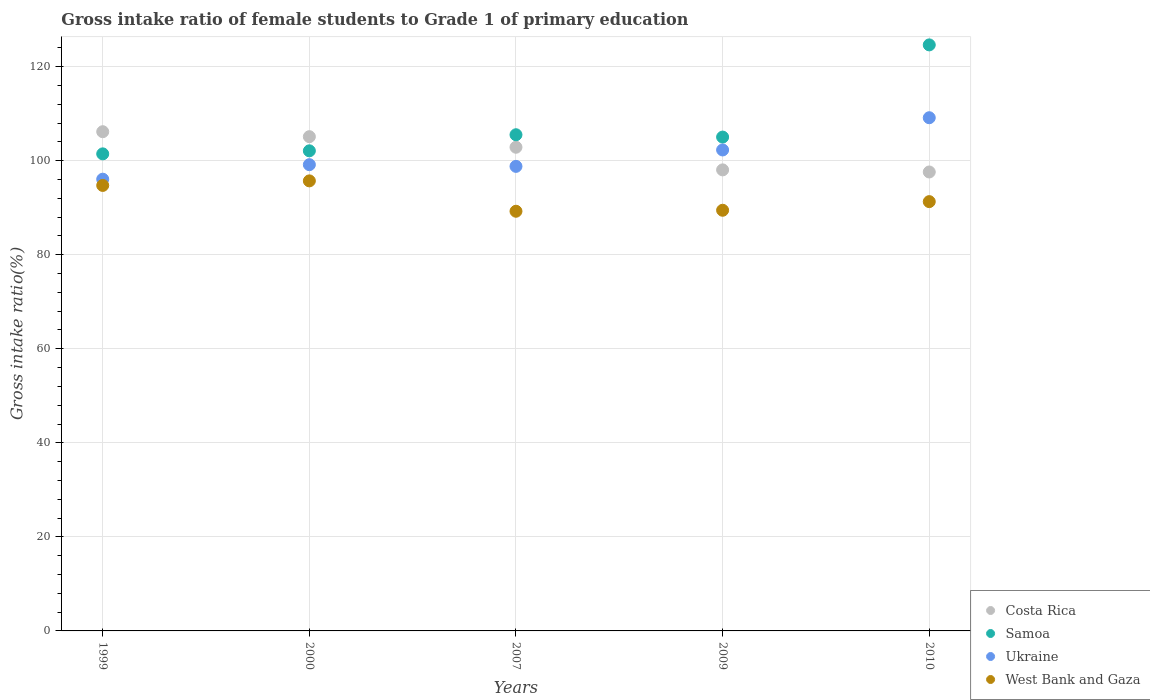Is the number of dotlines equal to the number of legend labels?
Make the answer very short. Yes. What is the gross intake ratio in Ukraine in 2010?
Provide a short and direct response. 109.14. Across all years, what is the maximum gross intake ratio in Costa Rica?
Keep it short and to the point. 106.16. Across all years, what is the minimum gross intake ratio in Samoa?
Provide a succinct answer. 101.45. In which year was the gross intake ratio in Costa Rica maximum?
Give a very brief answer. 1999. What is the total gross intake ratio in West Bank and Gaza in the graph?
Give a very brief answer. 460.45. What is the difference between the gross intake ratio in West Bank and Gaza in 2007 and that in 2009?
Keep it short and to the point. -0.21. What is the difference between the gross intake ratio in Ukraine in 2000 and the gross intake ratio in West Bank and Gaza in 2009?
Ensure brevity in your answer.  9.69. What is the average gross intake ratio in West Bank and Gaza per year?
Offer a very short reply. 92.09. In the year 2007, what is the difference between the gross intake ratio in Costa Rica and gross intake ratio in Samoa?
Give a very brief answer. -2.66. In how many years, is the gross intake ratio in West Bank and Gaza greater than 108 %?
Offer a terse response. 0. What is the ratio of the gross intake ratio in West Bank and Gaza in 2007 to that in 2010?
Keep it short and to the point. 0.98. What is the difference between the highest and the second highest gross intake ratio in Samoa?
Keep it short and to the point. 19.11. What is the difference between the highest and the lowest gross intake ratio in Costa Rica?
Make the answer very short. 8.56. In how many years, is the gross intake ratio in Samoa greater than the average gross intake ratio in Samoa taken over all years?
Your response must be concise. 1. Is the sum of the gross intake ratio in West Bank and Gaza in 2007 and 2010 greater than the maximum gross intake ratio in Samoa across all years?
Provide a short and direct response. Yes. Is it the case that in every year, the sum of the gross intake ratio in Ukraine and gross intake ratio in Costa Rica  is greater than the sum of gross intake ratio in Samoa and gross intake ratio in West Bank and Gaza?
Your answer should be compact. No. Is it the case that in every year, the sum of the gross intake ratio in West Bank and Gaza and gross intake ratio in Ukraine  is greater than the gross intake ratio in Costa Rica?
Provide a succinct answer. Yes. Is the gross intake ratio in Ukraine strictly greater than the gross intake ratio in Samoa over the years?
Give a very brief answer. No. Is the gross intake ratio in Ukraine strictly less than the gross intake ratio in Samoa over the years?
Keep it short and to the point. Yes. How many dotlines are there?
Provide a short and direct response. 4. How many years are there in the graph?
Offer a very short reply. 5. Where does the legend appear in the graph?
Your response must be concise. Bottom right. How are the legend labels stacked?
Provide a succinct answer. Vertical. What is the title of the graph?
Offer a very short reply. Gross intake ratio of female students to Grade 1 of primary education. What is the label or title of the X-axis?
Give a very brief answer. Years. What is the label or title of the Y-axis?
Your response must be concise. Gross intake ratio(%). What is the Gross intake ratio(%) in Costa Rica in 1999?
Your response must be concise. 106.16. What is the Gross intake ratio(%) of Samoa in 1999?
Make the answer very short. 101.45. What is the Gross intake ratio(%) of Ukraine in 1999?
Your answer should be compact. 96.07. What is the Gross intake ratio(%) of West Bank and Gaza in 1999?
Give a very brief answer. 94.74. What is the Gross intake ratio(%) in Costa Rica in 2000?
Offer a terse response. 105.11. What is the Gross intake ratio(%) of Samoa in 2000?
Provide a succinct answer. 102.1. What is the Gross intake ratio(%) in Ukraine in 2000?
Your answer should be very brief. 99.15. What is the Gross intake ratio(%) of West Bank and Gaza in 2000?
Your answer should be compact. 95.71. What is the Gross intake ratio(%) in Costa Rica in 2007?
Make the answer very short. 102.86. What is the Gross intake ratio(%) in Samoa in 2007?
Ensure brevity in your answer.  105.52. What is the Gross intake ratio(%) in Ukraine in 2007?
Offer a very short reply. 98.79. What is the Gross intake ratio(%) of West Bank and Gaza in 2007?
Provide a succinct answer. 89.25. What is the Gross intake ratio(%) of Costa Rica in 2009?
Offer a terse response. 98.05. What is the Gross intake ratio(%) in Samoa in 2009?
Your response must be concise. 105.02. What is the Gross intake ratio(%) of Ukraine in 2009?
Provide a short and direct response. 102.28. What is the Gross intake ratio(%) in West Bank and Gaza in 2009?
Provide a succinct answer. 89.46. What is the Gross intake ratio(%) of Costa Rica in 2010?
Your response must be concise. 97.6. What is the Gross intake ratio(%) in Samoa in 2010?
Provide a short and direct response. 124.63. What is the Gross intake ratio(%) of Ukraine in 2010?
Provide a short and direct response. 109.14. What is the Gross intake ratio(%) in West Bank and Gaza in 2010?
Provide a short and direct response. 91.29. Across all years, what is the maximum Gross intake ratio(%) of Costa Rica?
Your answer should be compact. 106.16. Across all years, what is the maximum Gross intake ratio(%) in Samoa?
Your answer should be compact. 124.63. Across all years, what is the maximum Gross intake ratio(%) in Ukraine?
Make the answer very short. 109.14. Across all years, what is the maximum Gross intake ratio(%) of West Bank and Gaza?
Give a very brief answer. 95.71. Across all years, what is the minimum Gross intake ratio(%) in Costa Rica?
Your answer should be very brief. 97.6. Across all years, what is the minimum Gross intake ratio(%) in Samoa?
Make the answer very short. 101.45. Across all years, what is the minimum Gross intake ratio(%) in Ukraine?
Provide a succinct answer. 96.07. Across all years, what is the minimum Gross intake ratio(%) in West Bank and Gaza?
Offer a terse response. 89.25. What is the total Gross intake ratio(%) of Costa Rica in the graph?
Your answer should be very brief. 509.77. What is the total Gross intake ratio(%) in Samoa in the graph?
Your response must be concise. 538.71. What is the total Gross intake ratio(%) of Ukraine in the graph?
Provide a short and direct response. 505.43. What is the total Gross intake ratio(%) in West Bank and Gaza in the graph?
Keep it short and to the point. 460.44. What is the difference between the Gross intake ratio(%) in Costa Rica in 1999 and that in 2000?
Your answer should be compact. 1.06. What is the difference between the Gross intake ratio(%) of Samoa in 1999 and that in 2000?
Make the answer very short. -0.65. What is the difference between the Gross intake ratio(%) in Ukraine in 1999 and that in 2000?
Ensure brevity in your answer.  -3.09. What is the difference between the Gross intake ratio(%) in West Bank and Gaza in 1999 and that in 2000?
Provide a short and direct response. -0.97. What is the difference between the Gross intake ratio(%) of Costa Rica in 1999 and that in 2007?
Keep it short and to the point. 3.3. What is the difference between the Gross intake ratio(%) in Samoa in 1999 and that in 2007?
Offer a terse response. -4.07. What is the difference between the Gross intake ratio(%) in Ukraine in 1999 and that in 2007?
Offer a very short reply. -2.73. What is the difference between the Gross intake ratio(%) in West Bank and Gaza in 1999 and that in 2007?
Offer a terse response. 5.49. What is the difference between the Gross intake ratio(%) in Costa Rica in 1999 and that in 2009?
Your answer should be compact. 8.12. What is the difference between the Gross intake ratio(%) in Samoa in 1999 and that in 2009?
Offer a very short reply. -3.57. What is the difference between the Gross intake ratio(%) in Ukraine in 1999 and that in 2009?
Your answer should be compact. -6.22. What is the difference between the Gross intake ratio(%) in West Bank and Gaza in 1999 and that in 2009?
Give a very brief answer. 5.28. What is the difference between the Gross intake ratio(%) in Costa Rica in 1999 and that in 2010?
Offer a terse response. 8.56. What is the difference between the Gross intake ratio(%) of Samoa in 1999 and that in 2010?
Keep it short and to the point. -23.17. What is the difference between the Gross intake ratio(%) in Ukraine in 1999 and that in 2010?
Offer a very short reply. -13.07. What is the difference between the Gross intake ratio(%) in West Bank and Gaza in 1999 and that in 2010?
Provide a succinct answer. 3.44. What is the difference between the Gross intake ratio(%) in Costa Rica in 2000 and that in 2007?
Offer a terse response. 2.25. What is the difference between the Gross intake ratio(%) in Samoa in 2000 and that in 2007?
Ensure brevity in your answer.  -3.42. What is the difference between the Gross intake ratio(%) in Ukraine in 2000 and that in 2007?
Give a very brief answer. 0.36. What is the difference between the Gross intake ratio(%) of West Bank and Gaza in 2000 and that in 2007?
Offer a very short reply. 6.46. What is the difference between the Gross intake ratio(%) in Costa Rica in 2000 and that in 2009?
Your answer should be very brief. 7.06. What is the difference between the Gross intake ratio(%) of Samoa in 2000 and that in 2009?
Your response must be concise. -2.92. What is the difference between the Gross intake ratio(%) in Ukraine in 2000 and that in 2009?
Your answer should be very brief. -3.13. What is the difference between the Gross intake ratio(%) of West Bank and Gaza in 2000 and that in 2009?
Provide a short and direct response. 6.25. What is the difference between the Gross intake ratio(%) in Costa Rica in 2000 and that in 2010?
Give a very brief answer. 7.51. What is the difference between the Gross intake ratio(%) in Samoa in 2000 and that in 2010?
Your response must be concise. -22.53. What is the difference between the Gross intake ratio(%) of Ukraine in 2000 and that in 2010?
Provide a succinct answer. -9.98. What is the difference between the Gross intake ratio(%) of West Bank and Gaza in 2000 and that in 2010?
Offer a terse response. 4.41. What is the difference between the Gross intake ratio(%) in Costa Rica in 2007 and that in 2009?
Ensure brevity in your answer.  4.82. What is the difference between the Gross intake ratio(%) of Samoa in 2007 and that in 2009?
Offer a terse response. 0.5. What is the difference between the Gross intake ratio(%) in Ukraine in 2007 and that in 2009?
Ensure brevity in your answer.  -3.49. What is the difference between the Gross intake ratio(%) in West Bank and Gaza in 2007 and that in 2009?
Keep it short and to the point. -0.21. What is the difference between the Gross intake ratio(%) of Costa Rica in 2007 and that in 2010?
Your answer should be very brief. 5.26. What is the difference between the Gross intake ratio(%) of Samoa in 2007 and that in 2010?
Offer a terse response. -19.11. What is the difference between the Gross intake ratio(%) in Ukraine in 2007 and that in 2010?
Your response must be concise. -10.34. What is the difference between the Gross intake ratio(%) in West Bank and Gaza in 2007 and that in 2010?
Offer a very short reply. -2.05. What is the difference between the Gross intake ratio(%) of Costa Rica in 2009 and that in 2010?
Make the answer very short. 0.45. What is the difference between the Gross intake ratio(%) of Samoa in 2009 and that in 2010?
Keep it short and to the point. -19.6. What is the difference between the Gross intake ratio(%) in Ukraine in 2009 and that in 2010?
Your answer should be very brief. -6.85. What is the difference between the Gross intake ratio(%) of West Bank and Gaza in 2009 and that in 2010?
Give a very brief answer. -1.84. What is the difference between the Gross intake ratio(%) in Costa Rica in 1999 and the Gross intake ratio(%) in Samoa in 2000?
Keep it short and to the point. 4.06. What is the difference between the Gross intake ratio(%) in Costa Rica in 1999 and the Gross intake ratio(%) in Ukraine in 2000?
Ensure brevity in your answer.  7.01. What is the difference between the Gross intake ratio(%) of Costa Rica in 1999 and the Gross intake ratio(%) of West Bank and Gaza in 2000?
Provide a short and direct response. 10.46. What is the difference between the Gross intake ratio(%) in Samoa in 1999 and the Gross intake ratio(%) in Ukraine in 2000?
Your answer should be compact. 2.3. What is the difference between the Gross intake ratio(%) in Samoa in 1999 and the Gross intake ratio(%) in West Bank and Gaza in 2000?
Provide a short and direct response. 5.74. What is the difference between the Gross intake ratio(%) in Ukraine in 1999 and the Gross intake ratio(%) in West Bank and Gaza in 2000?
Ensure brevity in your answer.  0.36. What is the difference between the Gross intake ratio(%) in Costa Rica in 1999 and the Gross intake ratio(%) in Samoa in 2007?
Ensure brevity in your answer.  0.65. What is the difference between the Gross intake ratio(%) of Costa Rica in 1999 and the Gross intake ratio(%) of Ukraine in 2007?
Offer a very short reply. 7.37. What is the difference between the Gross intake ratio(%) in Costa Rica in 1999 and the Gross intake ratio(%) in West Bank and Gaza in 2007?
Give a very brief answer. 16.92. What is the difference between the Gross intake ratio(%) in Samoa in 1999 and the Gross intake ratio(%) in Ukraine in 2007?
Ensure brevity in your answer.  2.66. What is the difference between the Gross intake ratio(%) of Samoa in 1999 and the Gross intake ratio(%) of West Bank and Gaza in 2007?
Provide a short and direct response. 12.2. What is the difference between the Gross intake ratio(%) in Ukraine in 1999 and the Gross intake ratio(%) in West Bank and Gaza in 2007?
Ensure brevity in your answer.  6.82. What is the difference between the Gross intake ratio(%) of Costa Rica in 1999 and the Gross intake ratio(%) of Samoa in 2009?
Provide a succinct answer. 1.14. What is the difference between the Gross intake ratio(%) of Costa Rica in 1999 and the Gross intake ratio(%) of Ukraine in 2009?
Your answer should be compact. 3.88. What is the difference between the Gross intake ratio(%) of Costa Rica in 1999 and the Gross intake ratio(%) of West Bank and Gaza in 2009?
Your answer should be compact. 16.7. What is the difference between the Gross intake ratio(%) of Samoa in 1999 and the Gross intake ratio(%) of Ukraine in 2009?
Your answer should be compact. -0.83. What is the difference between the Gross intake ratio(%) of Samoa in 1999 and the Gross intake ratio(%) of West Bank and Gaza in 2009?
Offer a terse response. 11.99. What is the difference between the Gross intake ratio(%) in Ukraine in 1999 and the Gross intake ratio(%) in West Bank and Gaza in 2009?
Offer a very short reply. 6.61. What is the difference between the Gross intake ratio(%) in Costa Rica in 1999 and the Gross intake ratio(%) in Samoa in 2010?
Your answer should be very brief. -18.46. What is the difference between the Gross intake ratio(%) of Costa Rica in 1999 and the Gross intake ratio(%) of Ukraine in 2010?
Make the answer very short. -2.97. What is the difference between the Gross intake ratio(%) of Costa Rica in 1999 and the Gross intake ratio(%) of West Bank and Gaza in 2010?
Offer a very short reply. 14.87. What is the difference between the Gross intake ratio(%) of Samoa in 1999 and the Gross intake ratio(%) of Ukraine in 2010?
Offer a very short reply. -7.68. What is the difference between the Gross intake ratio(%) of Samoa in 1999 and the Gross intake ratio(%) of West Bank and Gaza in 2010?
Make the answer very short. 10.16. What is the difference between the Gross intake ratio(%) of Ukraine in 1999 and the Gross intake ratio(%) of West Bank and Gaza in 2010?
Provide a short and direct response. 4.77. What is the difference between the Gross intake ratio(%) in Costa Rica in 2000 and the Gross intake ratio(%) in Samoa in 2007?
Provide a succinct answer. -0.41. What is the difference between the Gross intake ratio(%) in Costa Rica in 2000 and the Gross intake ratio(%) in Ukraine in 2007?
Provide a short and direct response. 6.31. What is the difference between the Gross intake ratio(%) of Costa Rica in 2000 and the Gross intake ratio(%) of West Bank and Gaza in 2007?
Make the answer very short. 15.86. What is the difference between the Gross intake ratio(%) in Samoa in 2000 and the Gross intake ratio(%) in Ukraine in 2007?
Your response must be concise. 3.3. What is the difference between the Gross intake ratio(%) in Samoa in 2000 and the Gross intake ratio(%) in West Bank and Gaza in 2007?
Provide a succinct answer. 12.85. What is the difference between the Gross intake ratio(%) in Ukraine in 2000 and the Gross intake ratio(%) in West Bank and Gaza in 2007?
Your answer should be very brief. 9.9. What is the difference between the Gross intake ratio(%) of Costa Rica in 2000 and the Gross intake ratio(%) of Samoa in 2009?
Make the answer very short. 0.08. What is the difference between the Gross intake ratio(%) of Costa Rica in 2000 and the Gross intake ratio(%) of Ukraine in 2009?
Your answer should be compact. 2.82. What is the difference between the Gross intake ratio(%) in Costa Rica in 2000 and the Gross intake ratio(%) in West Bank and Gaza in 2009?
Provide a succinct answer. 15.65. What is the difference between the Gross intake ratio(%) of Samoa in 2000 and the Gross intake ratio(%) of Ukraine in 2009?
Keep it short and to the point. -0.18. What is the difference between the Gross intake ratio(%) in Samoa in 2000 and the Gross intake ratio(%) in West Bank and Gaza in 2009?
Your response must be concise. 12.64. What is the difference between the Gross intake ratio(%) in Ukraine in 2000 and the Gross intake ratio(%) in West Bank and Gaza in 2009?
Provide a short and direct response. 9.69. What is the difference between the Gross intake ratio(%) in Costa Rica in 2000 and the Gross intake ratio(%) in Samoa in 2010?
Ensure brevity in your answer.  -19.52. What is the difference between the Gross intake ratio(%) in Costa Rica in 2000 and the Gross intake ratio(%) in Ukraine in 2010?
Offer a very short reply. -4.03. What is the difference between the Gross intake ratio(%) in Costa Rica in 2000 and the Gross intake ratio(%) in West Bank and Gaza in 2010?
Make the answer very short. 13.81. What is the difference between the Gross intake ratio(%) in Samoa in 2000 and the Gross intake ratio(%) in Ukraine in 2010?
Your answer should be compact. -7.04. What is the difference between the Gross intake ratio(%) in Samoa in 2000 and the Gross intake ratio(%) in West Bank and Gaza in 2010?
Make the answer very short. 10.8. What is the difference between the Gross intake ratio(%) in Ukraine in 2000 and the Gross intake ratio(%) in West Bank and Gaza in 2010?
Provide a succinct answer. 7.86. What is the difference between the Gross intake ratio(%) of Costa Rica in 2007 and the Gross intake ratio(%) of Samoa in 2009?
Make the answer very short. -2.16. What is the difference between the Gross intake ratio(%) in Costa Rica in 2007 and the Gross intake ratio(%) in Ukraine in 2009?
Give a very brief answer. 0.58. What is the difference between the Gross intake ratio(%) of Costa Rica in 2007 and the Gross intake ratio(%) of West Bank and Gaza in 2009?
Give a very brief answer. 13.4. What is the difference between the Gross intake ratio(%) of Samoa in 2007 and the Gross intake ratio(%) of Ukraine in 2009?
Provide a succinct answer. 3.24. What is the difference between the Gross intake ratio(%) in Samoa in 2007 and the Gross intake ratio(%) in West Bank and Gaza in 2009?
Your answer should be very brief. 16.06. What is the difference between the Gross intake ratio(%) in Ukraine in 2007 and the Gross intake ratio(%) in West Bank and Gaza in 2009?
Keep it short and to the point. 9.34. What is the difference between the Gross intake ratio(%) in Costa Rica in 2007 and the Gross intake ratio(%) in Samoa in 2010?
Your answer should be compact. -21.76. What is the difference between the Gross intake ratio(%) in Costa Rica in 2007 and the Gross intake ratio(%) in Ukraine in 2010?
Make the answer very short. -6.28. What is the difference between the Gross intake ratio(%) in Costa Rica in 2007 and the Gross intake ratio(%) in West Bank and Gaza in 2010?
Provide a succinct answer. 11.57. What is the difference between the Gross intake ratio(%) in Samoa in 2007 and the Gross intake ratio(%) in Ukraine in 2010?
Your answer should be very brief. -3.62. What is the difference between the Gross intake ratio(%) in Samoa in 2007 and the Gross intake ratio(%) in West Bank and Gaza in 2010?
Keep it short and to the point. 14.22. What is the difference between the Gross intake ratio(%) of Ukraine in 2007 and the Gross intake ratio(%) of West Bank and Gaza in 2010?
Ensure brevity in your answer.  7.5. What is the difference between the Gross intake ratio(%) of Costa Rica in 2009 and the Gross intake ratio(%) of Samoa in 2010?
Offer a very short reply. -26.58. What is the difference between the Gross intake ratio(%) in Costa Rica in 2009 and the Gross intake ratio(%) in Ukraine in 2010?
Keep it short and to the point. -11.09. What is the difference between the Gross intake ratio(%) of Costa Rica in 2009 and the Gross intake ratio(%) of West Bank and Gaza in 2010?
Offer a very short reply. 6.75. What is the difference between the Gross intake ratio(%) in Samoa in 2009 and the Gross intake ratio(%) in Ukraine in 2010?
Ensure brevity in your answer.  -4.11. What is the difference between the Gross intake ratio(%) of Samoa in 2009 and the Gross intake ratio(%) of West Bank and Gaza in 2010?
Give a very brief answer. 13.73. What is the difference between the Gross intake ratio(%) of Ukraine in 2009 and the Gross intake ratio(%) of West Bank and Gaza in 2010?
Ensure brevity in your answer.  10.99. What is the average Gross intake ratio(%) of Costa Rica per year?
Give a very brief answer. 101.95. What is the average Gross intake ratio(%) in Samoa per year?
Keep it short and to the point. 107.74. What is the average Gross intake ratio(%) of Ukraine per year?
Provide a short and direct response. 101.09. What is the average Gross intake ratio(%) in West Bank and Gaza per year?
Offer a very short reply. 92.09. In the year 1999, what is the difference between the Gross intake ratio(%) of Costa Rica and Gross intake ratio(%) of Samoa?
Your response must be concise. 4.71. In the year 1999, what is the difference between the Gross intake ratio(%) of Costa Rica and Gross intake ratio(%) of Ukraine?
Ensure brevity in your answer.  10.1. In the year 1999, what is the difference between the Gross intake ratio(%) in Costa Rica and Gross intake ratio(%) in West Bank and Gaza?
Provide a short and direct response. 11.42. In the year 1999, what is the difference between the Gross intake ratio(%) of Samoa and Gross intake ratio(%) of Ukraine?
Give a very brief answer. 5.39. In the year 1999, what is the difference between the Gross intake ratio(%) of Samoa and Gross intake ratio(%) of West Bank and Gaza?
Make the answer very short. 6.71. In the year 1999, what is the difference between the Gross intake ratio(%) in Ukraine and Gross intake ratio(%) in West Bank and Gaza?
Offer a very short reply. 1.33. In the year 2000, what is the difference between the Gross intake ratio(%) of Costa Rica and Gross intake ratio(%) of Samoa?
Your answer should be compact. 3.01. In the year 2000, what is the difference between the Gross intake ratio(%) in Costa Rica and Gross intake ratio(%) in Ukraine?
Make the answer very short. 5.95. In the year 2000, what is the difference between the Gross intake ratio(%) in Costa Rica and Gross intake ratio(%) in West Bank and Gaza?
Your answer should be very brief. 9.4. In the year 2000, what is the difference between the Gross intake ratio(%) of Samoa and Gross intake ratio(%) of Ukraine?
Your response must be concise. 2.95. In the year 2000, what is the difference between the Gross intake ratio(%) of Samoa and Gross intake ratio(%) of West Bank and Gaza?
Provide a short and direct response. 6.39. In the year 2000, what is the difference between the Gross intake ratio(%) in Ukraine and Gross intake ratio(%) in West Bank and Gaza?
Your answer should be very brief. 3.44. In the year 2007, what is the difference between the Gross intake ratio(%) in Costa Rica and Gross intake ratio(%) in Samoa?
Give a very brief answer. -2.66. In the year 2007, what is the difference between the Gross intake ratio(%) in Costa Rica and Gross intake ratio(%) in Ukraine?
Make the answer very short. 4.07. In the year 2007, what is the difference between the Gross intake ratio(%) of Costa Rica and Gross intake ratio(%) of West Bank and Gaza?
Offer a terse response. 13.61. In the year 2007, what is the difference between the Gross intake ratio(%) in Samoa and Gross intake ratio(%) in Ukraine?
Keep it short and to the point. 6.72. In the year 2007, what is the difference between the Gross intake ratio(%) in Samoa and Gross intake ratio(%) in West Bank and Gaza?
Provide a succinct answer. 16.27. In the year 2007, what is the difference between the Gross intake ratio(%) in Ukraine and Gross intake ratio(%) in West Bank and Gaza?
Give a very brief answer. 9.55. In the year 2009, what is the difference between the Gross intake ratio(%) in Costa Rica and Gross intake ratio(%) in Samoa?
Offer a terse response. -6.98. In the year 2009, what is the difference between the Gross intake ratio(%) of Costa Rica and Gross intake ratio(%) of Ukraine?
Offer a terse response. -4.24. In the year 2009, what is the difference between the Gross intake ratio(%) in Costa Rica and Gross intake ratio(%) in West Bank and Gaza?
Your answer should be very brief. 8.59. In the year 2009, what is the difference between the Gross intake ratio(%) in Samoa and Gross intake ratio(%) in Ukraine?
Ensure brevity in your answer.  2.74. In the year 2009, what is the difference between the Gross intake ratio(%) of Samoa and Gross intake ratio(%) of West Bank and Gaza?
Keep it short and to the point. 15.56. In the year 2009, what is the difference between the Gross intake ratio(%) in Ukraine and Gross intake ratio(%) in West Bank and Gaza?
Offer a very short reply. 12.82. In the year 2010, what is the difference between the Gross intake ratio(%) in Costa Rica and Gross intake ratio(%) in Samoa?
Ensure brevity in your answer.  -27.03. In the year 2010, what is the difference between the Gross intake ratio(%) of Costa Rica and Gross intake ratio(%) of Ukraine?
Keep it short and to the point. -11.54. In the year 2010, what is the difference between the Gross intake ratio(%) in Costa Rica and Gross intake ratio(%) in West Bank and Gaza?
Provide a short and direct response. 6.3. In the year 2010, what is the difference between the Gross intake ratio(%) of Samoa and Gross intake ratio(%) of Ukraine?
Keep it short and to the point. 15.49. In the year 2010, what is the difference between the Gross intake ratio(%) in Samoa and Gross intake ratio(%) in West Bank and Gaza?
Ensure brevity in your answer.  33.33. In the year 2010, what is the difference between the Gross intake ratio(%) in Ukraine and Gross intake ratio(%) in West Bank and Gaza?
Offer a very short reply. 17.84. What is the ratio of the Gross intake ratio(%) in Costa Rica in 1999 to that in 2000?
Provide a succinct answer. 1.01. What is the ratio of the Gross intake ratio(%) in Ukraine in 1999 to that in 2000?
Your answer should be very brief. 0.97. What is the ratio of the Gross intake ratio(%) in Costa Rica in 1999 to that in 2007?
Offer a terse response. 1.03. What is the ratio of the Gross intake ratio(%) of Samoa in 1999 to that in 2007?
Offer a very short reply. 0.96. What is the ratio of the Gross intake ratio(%) of Ukraine in 1999 to that in 2007?
Provide a short and direct response. 0.97. What is the ratio of the Gross intake ratio(%) in West Bank and Gaza in 1999 to that in 2007?
Your answer should be compact. 1.06. What is the ratio of the Gross intake ratio(%) in Costa Rica in 1999 to that in 2009?
Your answer should be compact. 1.08. What is the ratio of the Gross intake ratio(%) of Samoa in 1999 to that in 2009?
Keep it short and to the point. 0.97. What is the ratio of the Gross intake ratio(%) of Ukraine in 1999 to that in 2009?
Ensure brevity in your answer.  0.94. What is the ratio of the Gross intake ratio(%) in West Bank and Gaza in 1999 to that in 2009?
Give a very brief answer. 1.06. What is the ratio of the Gross intake ratio(%) of Costa Rica in 1999 to that in 2010?
Provide a succinct answer. 1.09. What is the ratio of the Gross intake ratio(%) of Samoa in 1999 to that in 2010?
Keep it short and to the point. 0.81. What is the ratio of the Gross intake ratio(%) in Ukraine in 1999 to that in 2010?
Your response must be concise. 0.88. What is the ratio of the Gross intake ratio(%) of West Bank and Gaza in 1999 to that in 2010?
Provide a short and direct response. 1.04. What is the ratio of the Gross intake ratio(%) of Costa Rica in 2000 to that in 2007?
Keep it short and to the point. 1.02. What is the ratio of the Gross intake ratio(%) of Samoa in 2000 to that in 2007?
Give a very brief answer. 0.97. What is the ratio of the Gross intake ratio(%) of Ukraine in 2000 to that in 2007?
Your response must be concise. 1. What is the ratio of the Gross intake ratio(%) in West Bank and Gaza in 2000 to that in 2007?
Offer a terse response. 1.07. What is the ratio of the Gross intake ratio(%) in Costa Rica in 2000 to that in 2009?
Make the answer very short. 1.07. What is the ratio of the Gross intake ratio(%) in Samoa in 2000 to that in 2009?
Offer a very short reply. 0.97. What is the ratio of the Gross intake ratio(%) of Ukraine in 2000 to that in 2009?
Ensure brevity in your answer.  0.97. What is the ratio of the Gross intake ratio(%) in West Bank and Gaza in 2000 to that in 2009?
Keep it short and to the point. 1.07. What is the ratio of the Gross intake ratio(%) of Costa Rica in 2000 to that in 2010?
Offer a very short reply. 1.08. What is the ratio of the Gross intake ratio(%) of Samoa in 2000 to that in 2010?
Your response must be concise. 0.82. What is the ratio of the Gross intake ratio(%) in Ukraine in 2000 to that in 2010?
Make the answer very short. 0.91. What is the ratio of the Gross intake ratio(%) of West Bank and Gaza in 2000 to that in 2010?
Your answer should be very brief. 1.05. What is the ratio of the Gross intake ratio(%) of Costa Rica in 2007 to that in 2009?
Offer a terse response. 1.05. What is the ratio of the Gross intake ratio(%) in Ukraine in 2007 to that in 2009?
Your answer should be compact. 0.97. What is the ratio of the Gross intake ratio(%) of West Bank and Gaza in 2007 to that in 2009?
Make the answer very short. 1. What is the ratio of the Gross intake ratio(%) in Costa Rica in 2007 to that in 2010?
Your response must be concise. 1.05. What is the ratio of the Gross intake ratio(%) in Samoa in 2007 to that in 2010?
Your answer should be compact. 0.85. What is the ratio of the Gross intake ratio(%) in Ukraine in 2007 to that in 2010?
Your answer should be very brief. 0.91. What is the ratio of the Gross intake ratio(%) in West Bank and Gaza in 2007 to that in 2010?
Your answer should be compact. 0.98. What is the ratio of the Gross intake ratio(%) of Samoa in 2009 to that in 2010?
Keep it short and to the point. 0.84. What is the ratio of the Gross intake ratio(%) of Ukraine in 2009 to that in 2010?
Your response must be concise. 0.94. What is the ratio of the Gross intake ratio(%) in West Bank and Gaza in 2009 to that in 2010?
Give a very brief answer. 0.98. What is the difference between the highest and the second highest Gross intake ratio(%) of Costa Rica?
Give a very brief answer. 1.06. What is the difference between the highest and the second highest Gross intake ratio(%) of Samoa?
Your answer should be very brief. 19.11. What is the difference between the highest and the second highest Gross intake ratio(%) of Ukraine?
Your answer should be very brief. 6.85. What is the difference between the highest and the second highest Gross intake ratio(%) in West Bank and Gaza?
Give a very brief answer. 0.97. What is the difference between the highest and the lowest Gross intake ratio(%) of Costa Rica?
Provide a succinct answer. 8.56. What is the difference between the highest and the lowest Gross intake ratio(%) in Samoa?
Your answer should be very brief. 23.17. What is the difference between the highest and the lowest Gross intake ratio(%) of Ukraine?
Offer a terse response. 13.07. What is the difference between the highest and the lowest Gross intake ratio(%) of West Bank and Gaza?
Offer a terse response. 6.46. 